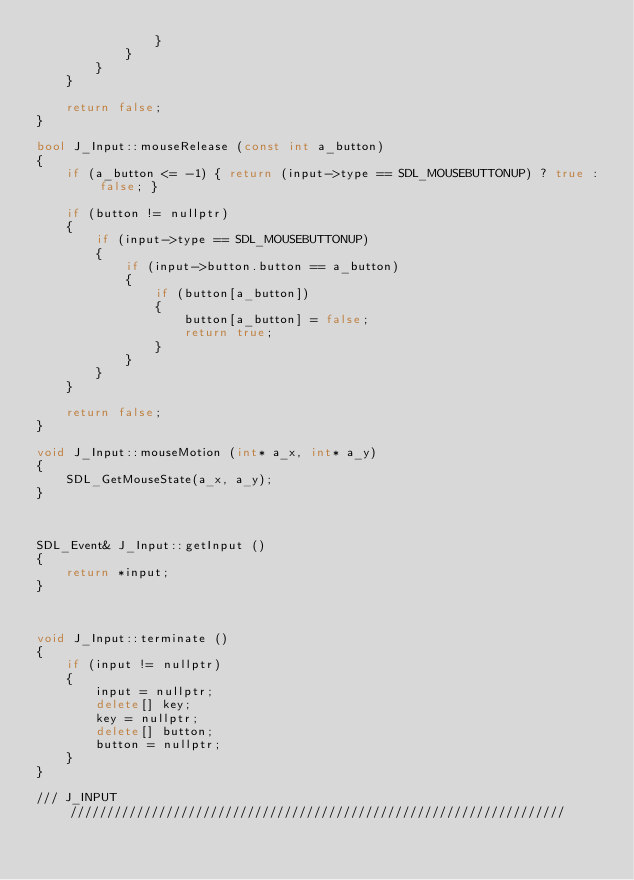Convert code to text. <code><loc_0><loc_0><loc_500><loc_500><_C++_>                }
            }
        }
    }

    return false;
}

bool J_Input::mouseRelease (const int a_button)
{
    if (a_button <= -1) { return (input->type == SDL_MOUSEBUTTONUP) ? true : false; }

    if (button != nullptr)
    {
        if (input->type == SDL_MOUSEBUTTONUP)
        {
            if (input->button.button == a_button)
            {
                if (button[a_button])
                {
                    button[a_button] = false;
                    return true;
                }
            }
        }
    }

    return false;
}

void J_Input::mouseMotion (int* a_x, int* a_y)
{
    SDL_GetMouseState(a_x, a_y);
}



SDL_Event& J_Input::getInput ()
{
    return *input;
}



void J_Input::terminate ()
{
    if (input != nullptr)
    {
        input = nullptr;
        delete[] key;
        key = nullptr;
        delete[] button;
        button = nullptr;
    }
}

/// J_INPUT ///////////////////////////////////////////////////////////////////
</code> 